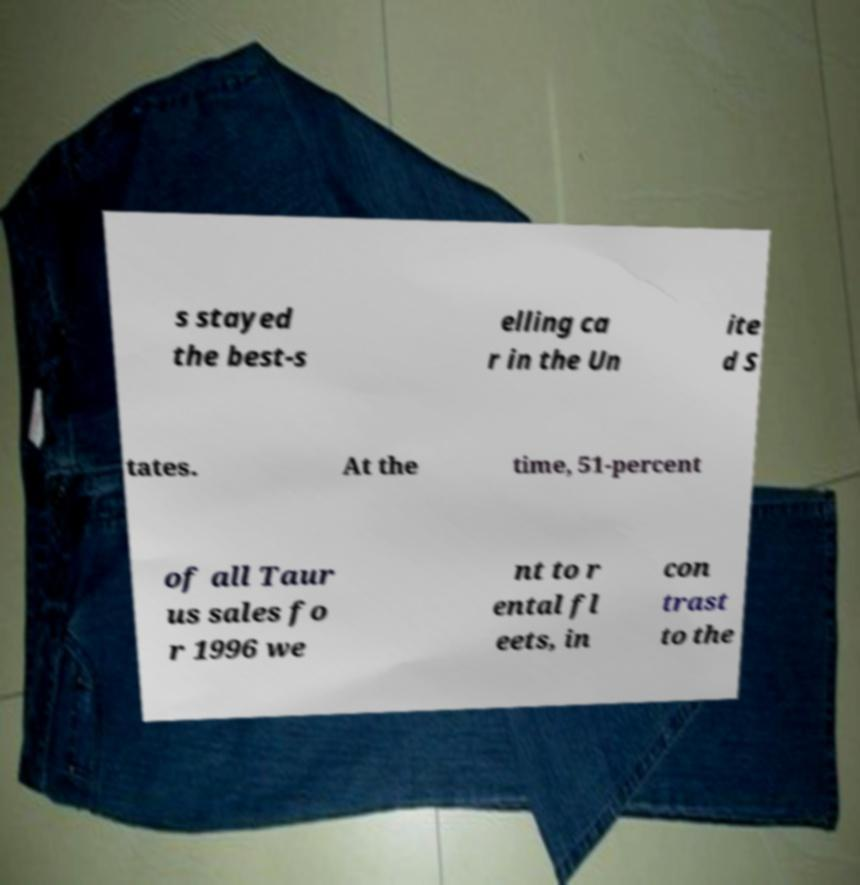There's text embedded in this image that I need extracted. Can you transcribe it verbatim? s stayed the best-s elling ca r in the Un ite d S tates. At the time, 51-percent of all Taur us sales fo r 1996 we nt to r ental fl eets, in con trast to the 